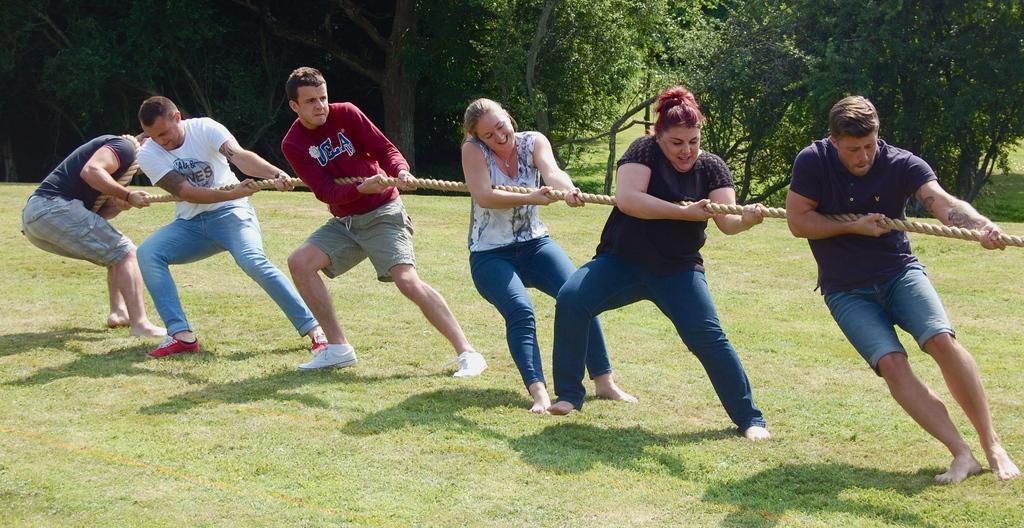How would you summarize this image in a sentence or two? In this image few persons are standing on the grass land. They are holding rope. Behind them there are few trees are on the grass land. A person wearing a white shirt is wearing shoes. 